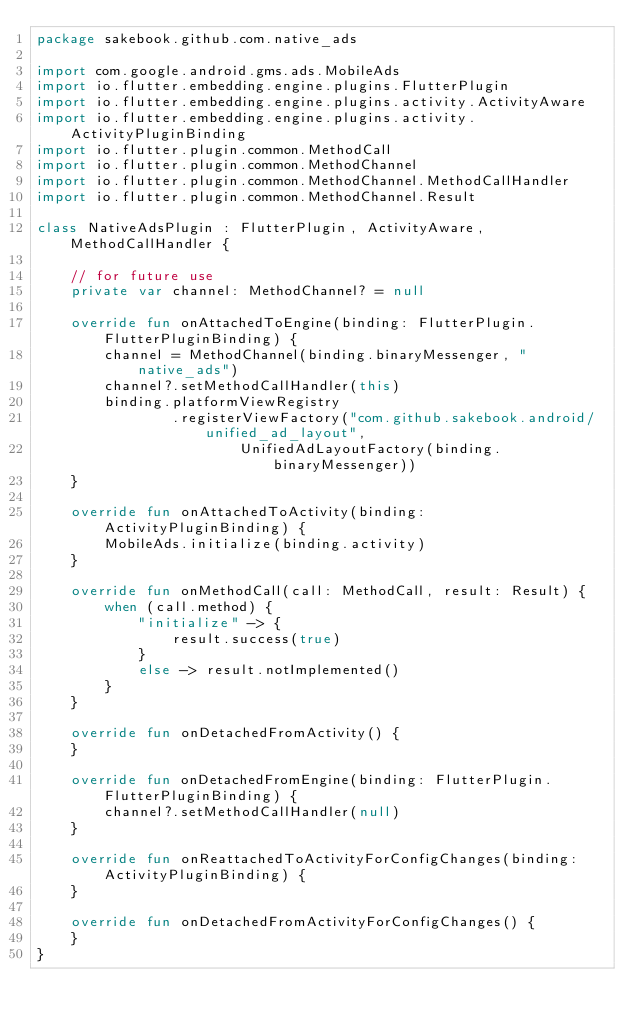Convert code to text. <code><loc_0><loc_0><loc_500><loc_500><_Kotlin_>package sakebook.github.com.native_ads

import com.google.android.gms.ads.MobileAds
import io.flutter.embedding.engine.plugins.FlutterPlugin
import io.flutter.embedding.engine.plugins.activity.ActivityAware
import io.flutter.embedding.engine.plugins.activity.ActivityPluginBinding
import io.flutter.plugin.common.MethodCall
import io.flutter.plugin.common.MethodChannel
import io.flutter.plugin.common.MethodChannel.MethodCallHandler
import io.flutter.plugin.common.MethodChannel.Result

class NativeAdsPlugin : FlutterPlugin, ActivityAware, MethodCallHandler {

    // for future use
    private var channel: MethodChannel? = null

    override fun onAttachedToEngine(binding: FlutterPlugin.FlutterPluginBinding) {
        channel = MethodChannel(binding.binaryMessenger, "native_ads")
        channel?.setMethodCallHandler(this)
        binding.platformViewRegistry
                .registerViewFactory("com.github.sakebook.android/unified_ad_layout",
                        UnifiedAdLayoutFactory(binding.binaryMessenger))
    }

    override fun onAttachedToActivity(binding: ActivityPluginBinding) {
        MobileAds.initialize(binding.activity)
    }

    override fun onMethodCall(call: MethodCall, result: Result) {
        when (call.method) {
            "initialize" -> {
                result.success(true)
            }
            else -> result.notImplemented()
        }
    }

    override fun onDetachedFromActivity() {
    }

    override fun onDetachedFromEngine(binding: FlutterPlugin.FlutterPluginBinding) {
        channel?.setMethodCallHandler(null)
    }

    override fun onReattachedToActivityForConfigChanges(binding: ActivityPluginBinding) {
    }

    override fun onDetachedFromActivityForConfigChanges() {
    }
}</code> 